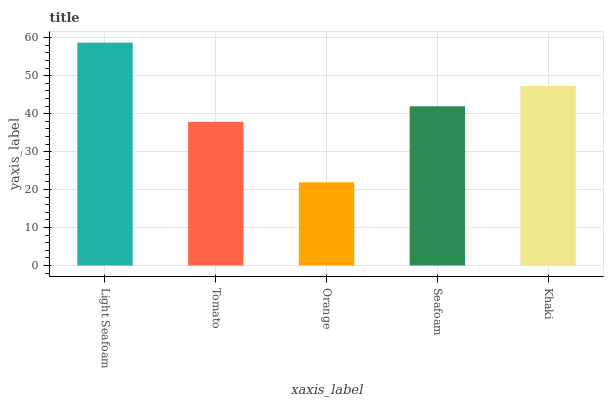Is Orange the minimum?
Answer yes or no. Yes. Is Light Seafoam the maximum?
Answer yes or no. Yes. Is Tomato the minimum?
Answer yes or no. No. Is Tomato the maximum?
Answer yes or no. No. Is Light Seafoam greater than Tomato?
Answer yes or no. Yes. Is Tomato less than Light Seafoam?
Answer yes or no. Yes. Is Tomato greater than Light Seafoam?
Answer yes or no. No. Is Light Seafoam less than Tomato?
Answer yes or no. No. Is Seafoam the high median?
Answer yes or no. Yes. Is Seafoam the low median?
Answer yes or no. Yes. Is Khaki the high median?
Answer yes or no. No. Is Tomato the low median?
Answer yes or no. No. 